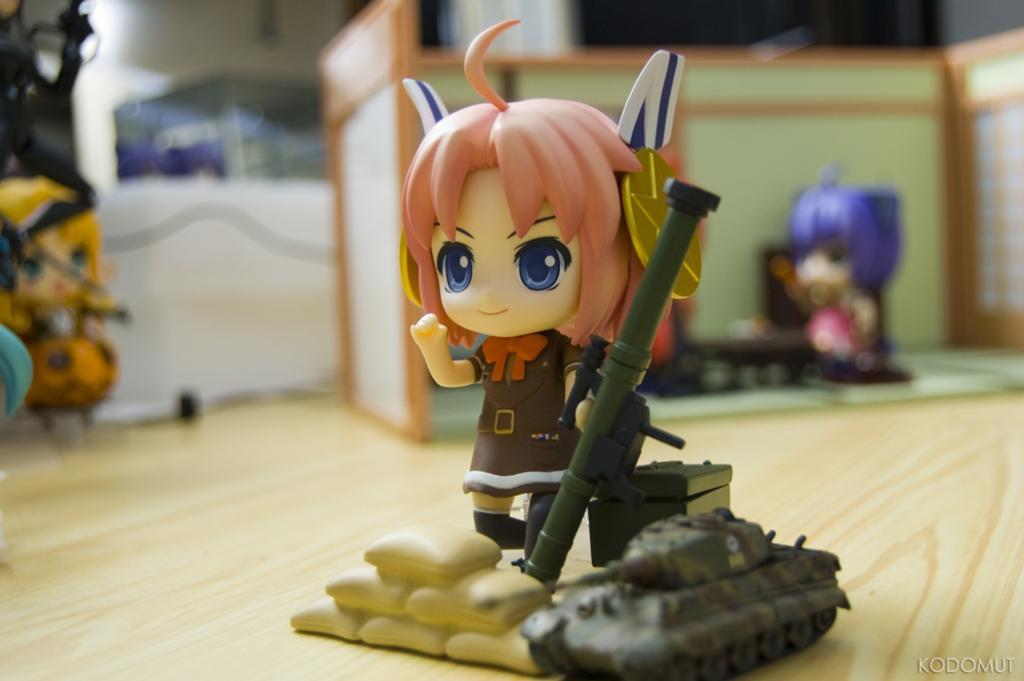Describe this image in one or two sentences. In the center of the image, we can see toys and in the background, there are some other toys and there is a wall. At the bottom, there is floor. 